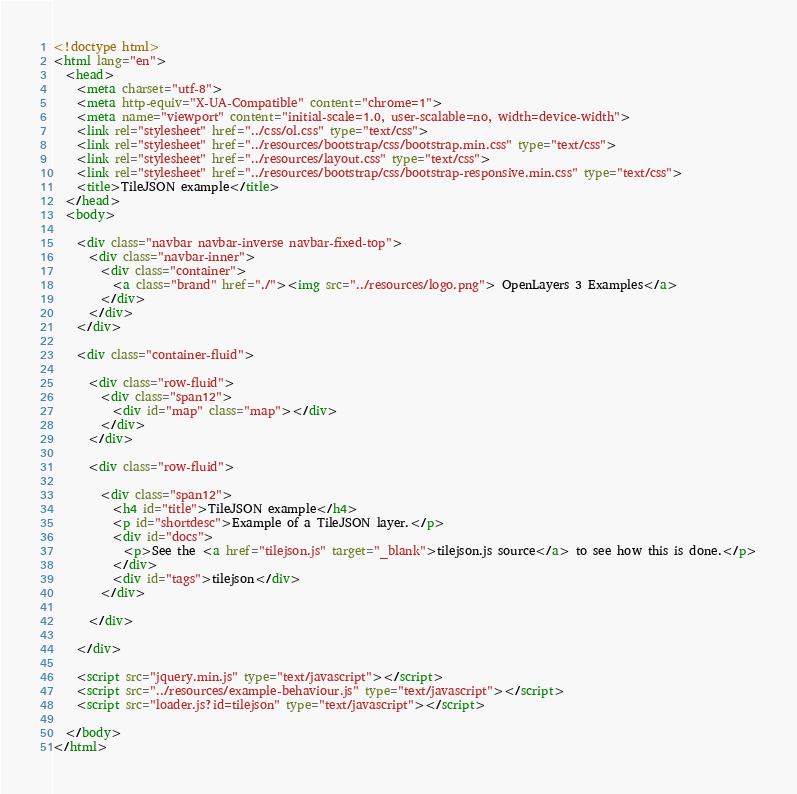<code> <loc_0><loc_0><loc_500><loc_500><_HTML_><!doctype html>
<html lang="en">
  <head>
    <meta charset="utf-8">
    <meta http-equiv="X-UA-Compatible" content="chrome=1">
    <meta name="viewport" content="initial-scale=1.0, user-scalable=no, width=device-width">
    <link rel="stylesheet" href="../css/ol.css" type="text/css">
    <link rel="stylesheet" href="../resources/bootstrap/css/bootstrap.min.css" type="text/css">
    <link rel="stylesheet" href="../resources/layout.css" type="text/css">
    <link rel="stylesheet" href="../resources/bootstrap/css/bootstrap-responsive.min.css" type="text/css">
    <title>TileJSON example</title>
  </head>
  <body>

    <div class="navbar navbar-inverse navbar-fixed-top">
      <div class="navbar-inner">
        <div class="container">
          <a class="brand" href="./"><img src="../resources/logo.png"> OpenLayers 3 Examples</a>
        </div>
      </div>
    </div>

    <div class="container-fluid">

      <div class="row-fluid">
        <div class="span12">
          <div id="map" class="map"></div>
        </div>
      </div>

      <div class="row-fluid">

        <div class="span12">
          <h4 id="title">TileJSON example</h4>
          <p id="shortdesc">Example of a TileJSON layer.</p>
          <div id="docs">
            <p>See the <a href="tilejson.js" target="_blank">tilejson.js source</a> to see how this is done.</p>
          </div>
          <div id="tags">tilejson</div>
        </div>

      </div>

    </div>

    <script src="jquery.min.js" type="text/javascript"></script>
    <script src="../resources/example-behaviour.js" type="text/javascript"></script>
    <script src="loader.js?id=tilejson" type="text/javascript"></script>

  </body>
</html>
</code> 